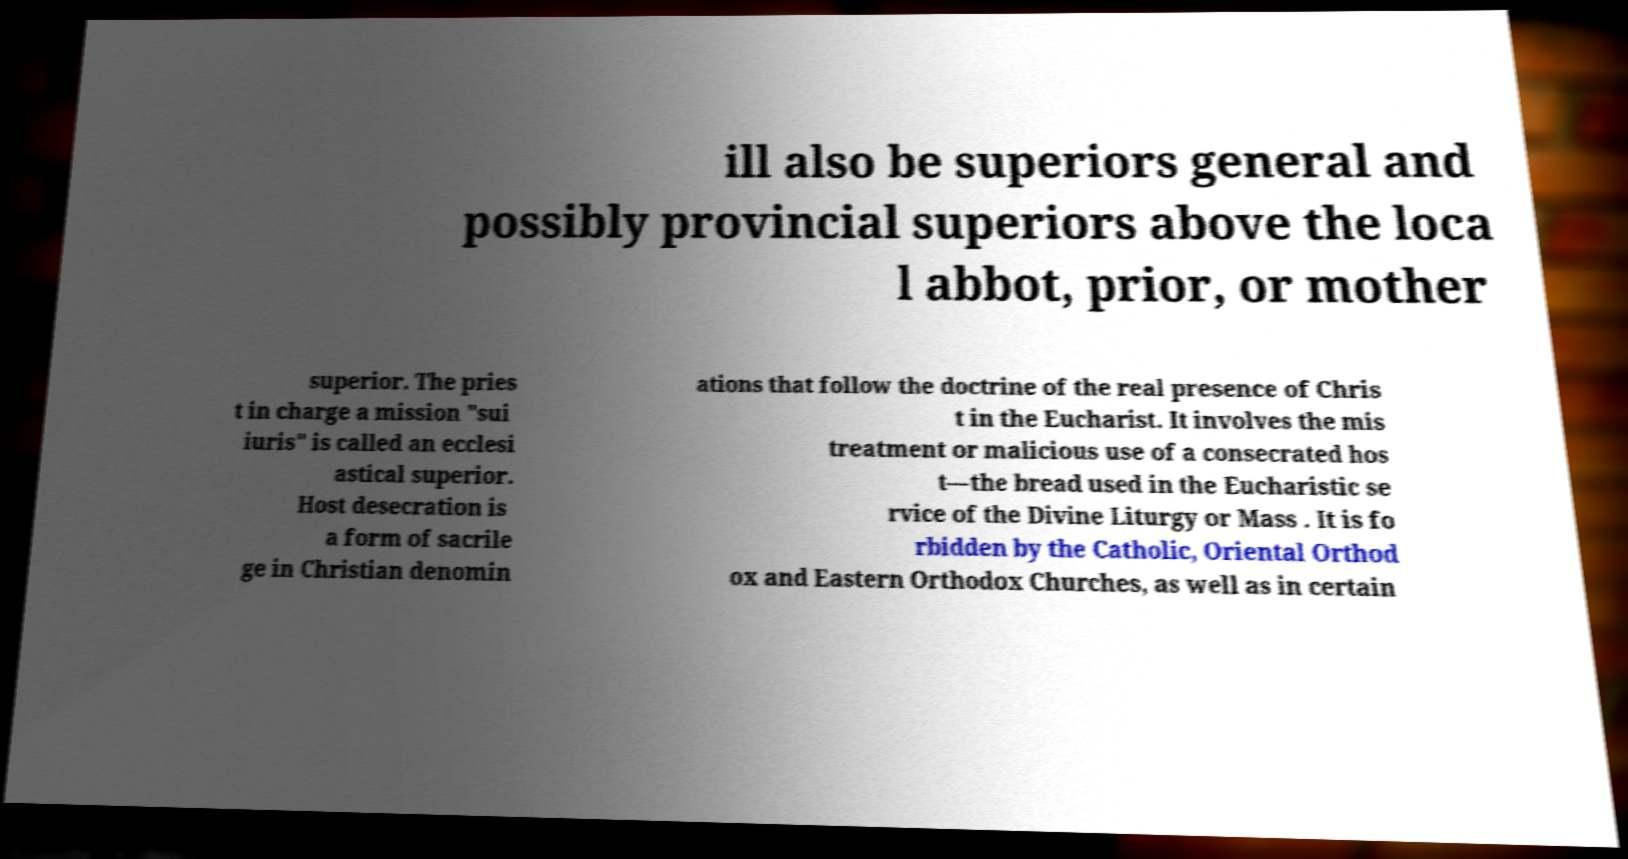Could you extract and type out the text from this image? ill also be superiors general and possibly provincial superiors above the loca l abbot, prior, or mother superior. The pries t in charge a mission "sui iuris" is called an ecclesi astical superior. Host desecration is a form of sacrile ge in Christian denomin ations that follow the doctrine of the real presence of Chris t in the Eucharist. It involves the mis treatment or malicious use of a consecrated hos t—the bread used in the Eucharistic se rvice of the Divine Liturgy or Mass . It is fo rbidden by the Catholic, Oriental Orthod ox and Eastern Orthodox Churches, as well as in certain 